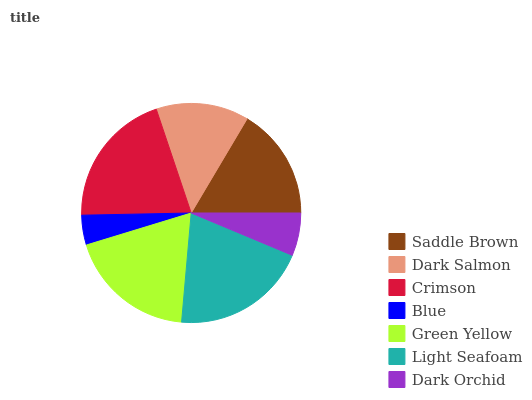Is Blue the minimum?
Answer yes or no. Yes. Is Crimson the maximum?
Answer yes or no. Yes. Is Dark Salmon the minimum?
Answer yes or no. No. Is Dark Salmon the maximum?
Answer yes or no. No. Is Saddle Brown greater than Dark Salmon?
Answer yes or no. Yes. Is Dark Salmon less than Saddle Brown?
Answer yes or no. Yes. Is Dark Salmon greater than Saddle Brown?
Answer yes or no. No. Is Saddle Brown less than Dark Salmon?
Answer yes or no. No. Is Saddle Brown the high median?
Answer yes or no. Yes. Is Saddle Brown the low median?
Answer yes or no. Yes. Is Dark Salmon the high median?
Answer yes or no. No. Is Green Yellow the low median?
Answer yes or no. No. 